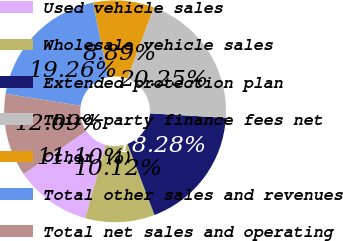Convert chart. <chart><loc_0><loc_0><loc_500><loc_500><pie_chart><fcel>Used vehicle sales<fcel>Wholesale vehicle sales<fcel>Extended protection plan<fcel>Third-party finance fees net<fcel>Other (1)<fcel>Total other sales and revenues<fcel>Total net sales and operating<nl><fcel>11.1%<fcel>10.12%<fcel>18.28%<fcel>20.25%<fcel>8.89%<fcel>19.26%<fcel>12.09%<nl></chart> 